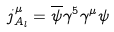Convert formula to latex. <formula><loc_0><loc_0><loc_500><loc_500>j ^ { \mu } _ { A _ { l } } = \overline { \psi } \gamma ^ { 5 } \gamma ^ { \mu } \psi</formula> 